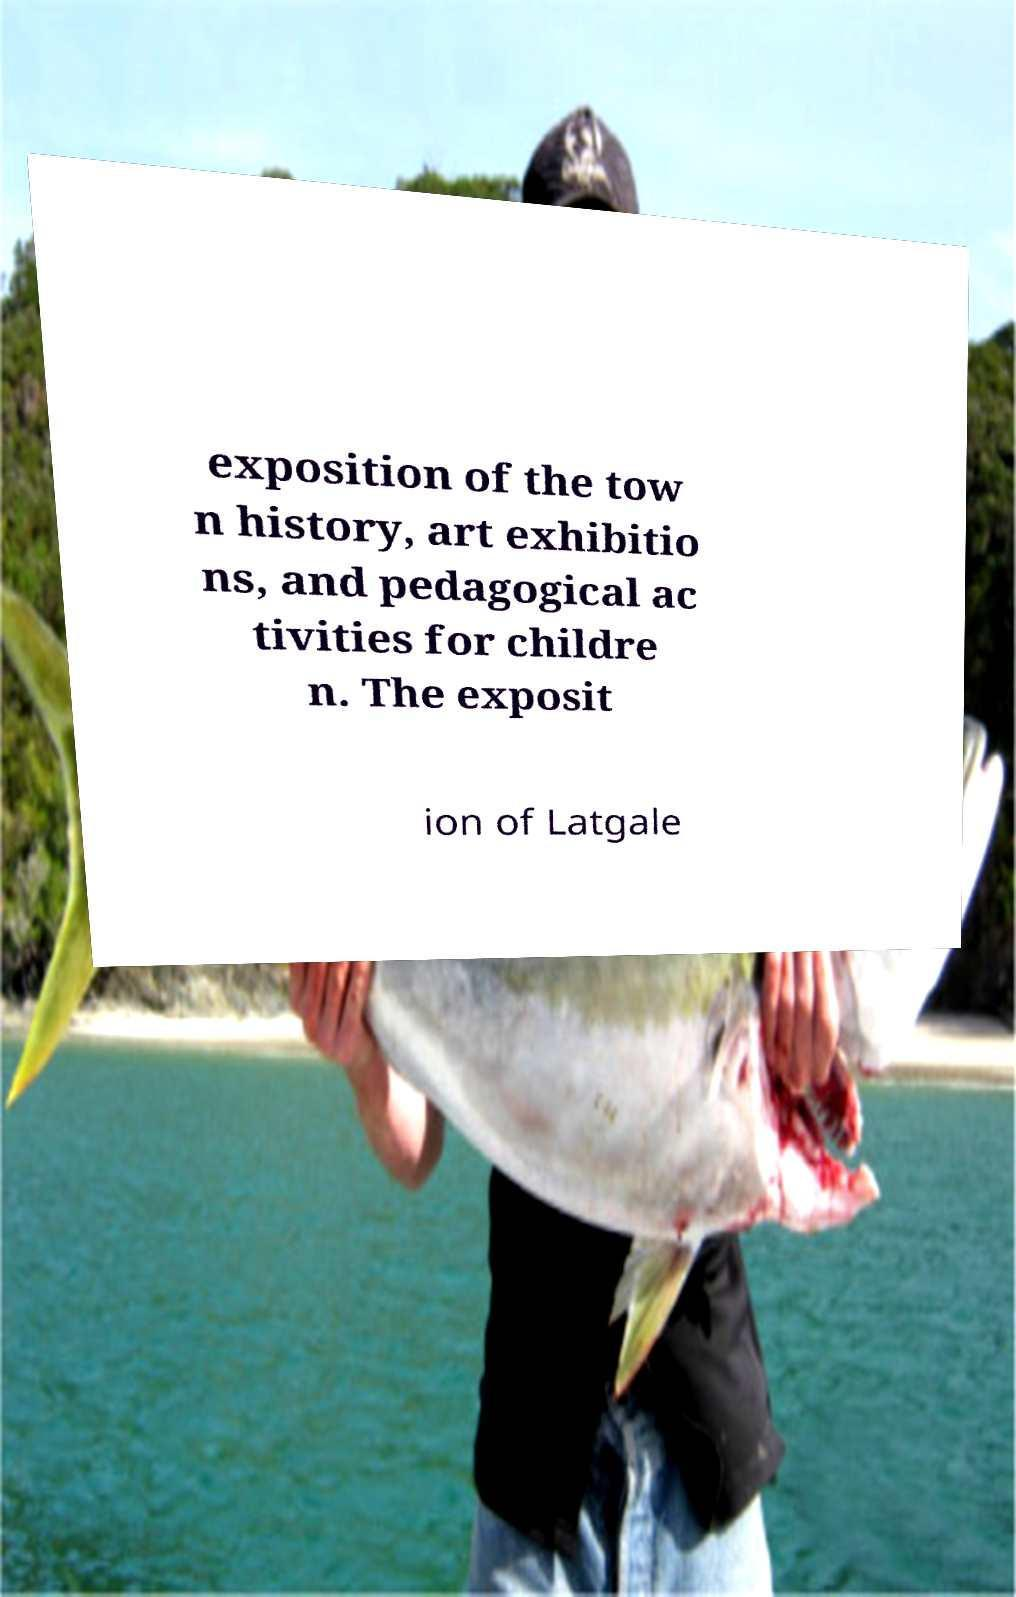What messages or text are displayed in this image? I need them in a readable, typed format. exposition of the tow n history, art exhibitio ns, and pedagogical ac tivities for childre n. The exposit ion of Latgale 